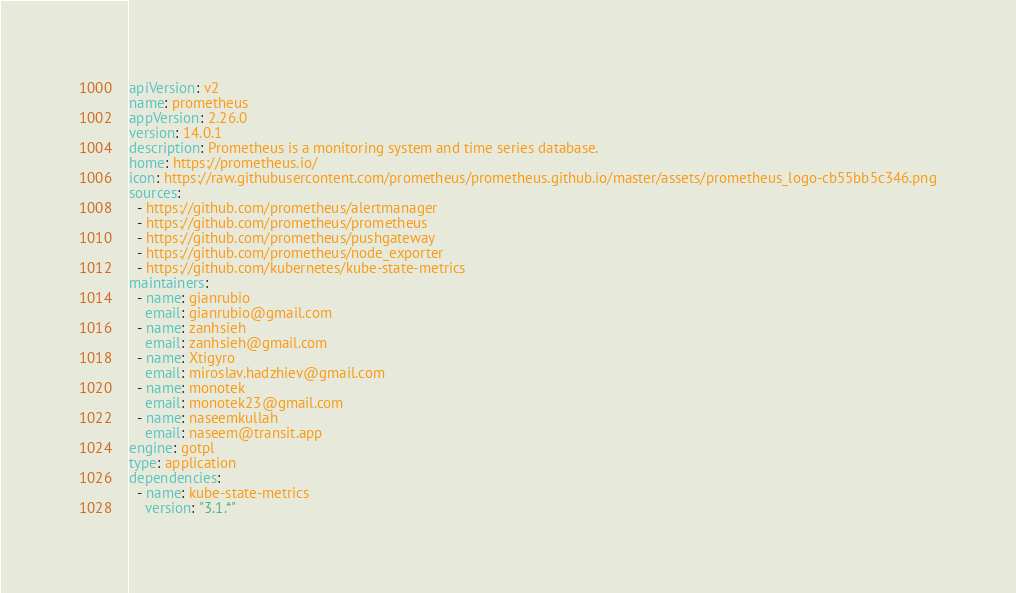Convert code to text. <code><loc_0><loc_0><loc_500><loc_500><_YAML_>apiVersion: v2
name: prometheus
appVersion: 2.26.0
version: 14.0.1
description: Prometheus is a monitoring system and time series database.
home: https://prometheus.io/
icon: https://raw.githubusercontent.com/prometheus/prometheus.github.io/master/assets/prometheus_logo-cb55bb5c346.png
sources:
  - https://github.com/prometheus/alertmanager
  - https://github.com/prometheus/prometheus
  - https://github.com/prometheus/pushgateway
  - https://github.com/prometheus/node_exporter
  - https://github.com/kubernetes/kube-state-metrics
maintainers:
  - name: gianrubio
    email: gianrubio@gmail.com
  - name: zanhsieh
    email: zanhsieh@gmail.com
  - name: Xtigyro
    email: miroslav.hadzhiev@gmail.com
  - name: monotek
    email: monotek23@gmail.com
  - name: naseemkullah
    email: naseem@transit.app
engine: gotpl
type: application
dependencies:
  - name: kube-state-metrics
    version: "3.1.*"</code> 